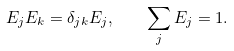Convert formula to latex. <formula><loc_0><loc_0><loc_500><loc_500>E _ { j } E _ { k } = \delta _ { j k } E _ { j } , \quad \sum _ { j } E _ { j } = 1 .</formula> 